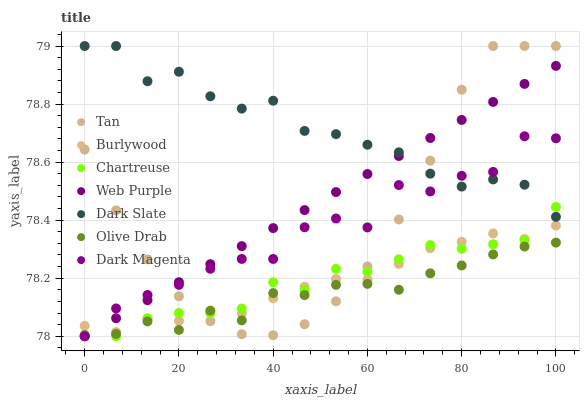Does Olive Drab have the minimum area under the curve?
Answer yes or no. Yes. Does Dark Slate have the maximum area under the curve?
Answer yes or no. Yes. Does Burlywood have the minimum area under the curve?
Answer yes or no. No. Does Burlywood have the maximum area under the curve?
Answer yes or no. No. Is Web Purple the smoothest?
Answer yes or no. Yes. Is Dark Magenta the roughest?
Answer yes or no. Yes. Is Burlywood the smoothest?
Answer yes or no. No. Is Burlywood the roughest?
Answer yes or no. No. Does Dark Magenta have the lowest value?
Answer yes or no. Yes. Does Burlywood have the lowest value?
Answer yes or no. No. Does Tan have the highest value?
Answer yes or no. Yes. Does Burlywood have the highest value?
Answer yes or no. No. Is Burlywood less than Dark Slate?
Answer yes or no. Yes. Is Dark Slate greater than Olive Drab?
Answer yes or no. Yes. Does Dark Magenta intersect Tan?
Answer yes or no. Yes. Is Dark Magenta less than Tan?
Answer yes or no. No. Is Dark Magenta greater than Tan?
Answer yes or no. No. Does Burlywood intersect Dark Slate?
Answer yes or no. No. 